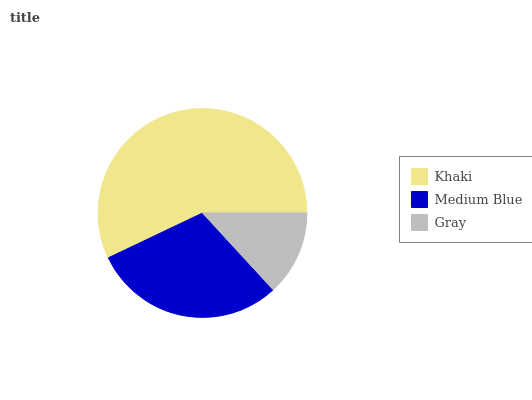Is Gray the minimum?
Answer yes or no. Yes. Is Khaki the maximum?
Answer yes or no. Yes. Is Medium Blue the minimum?
Answer yes or no. No. Is Medium Blue the maximum?
Answer yes or no. No. Is Khaki greater than Medium Blue?
Answer yes or no. Yes. Is Medium Blue less than Khaki?
Answer yes or no. Yes. Is Medium Blue greater than Khaki?
Answer yes or no. No. Is Khaki less than Medium Blue?
Answer yes or no. No. Is Medium Blue the high median?
Answer yes or no. Yes. Is Medium Blue the low median?
Answer yes or no. Yes. Is Khaki the high median?
Answer yes or no. No. Is Khaki the low median?
Answer yes or no. No. 